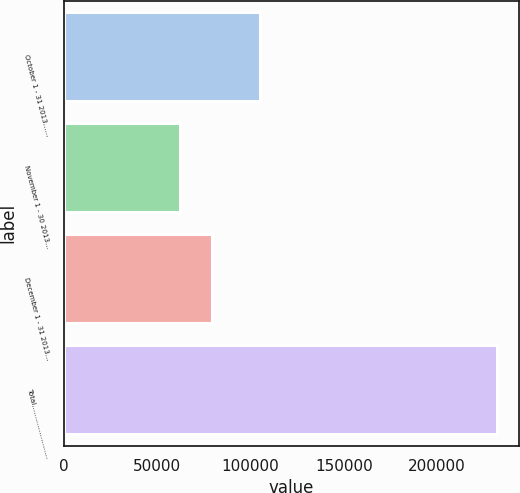Convert chart to OTSL. <chart><loc_0><loc_0><loc_500><loc_500><bar_chart><fcel>October 1 - 31 2013……<fcel>November 1 - 30 2013…<fcel>December 1 - 31 2013…<fcel>Total……………………<nl><fcel>105167<fcel>62312<fcel>79290.7<fcel>232099<nl></chart> 